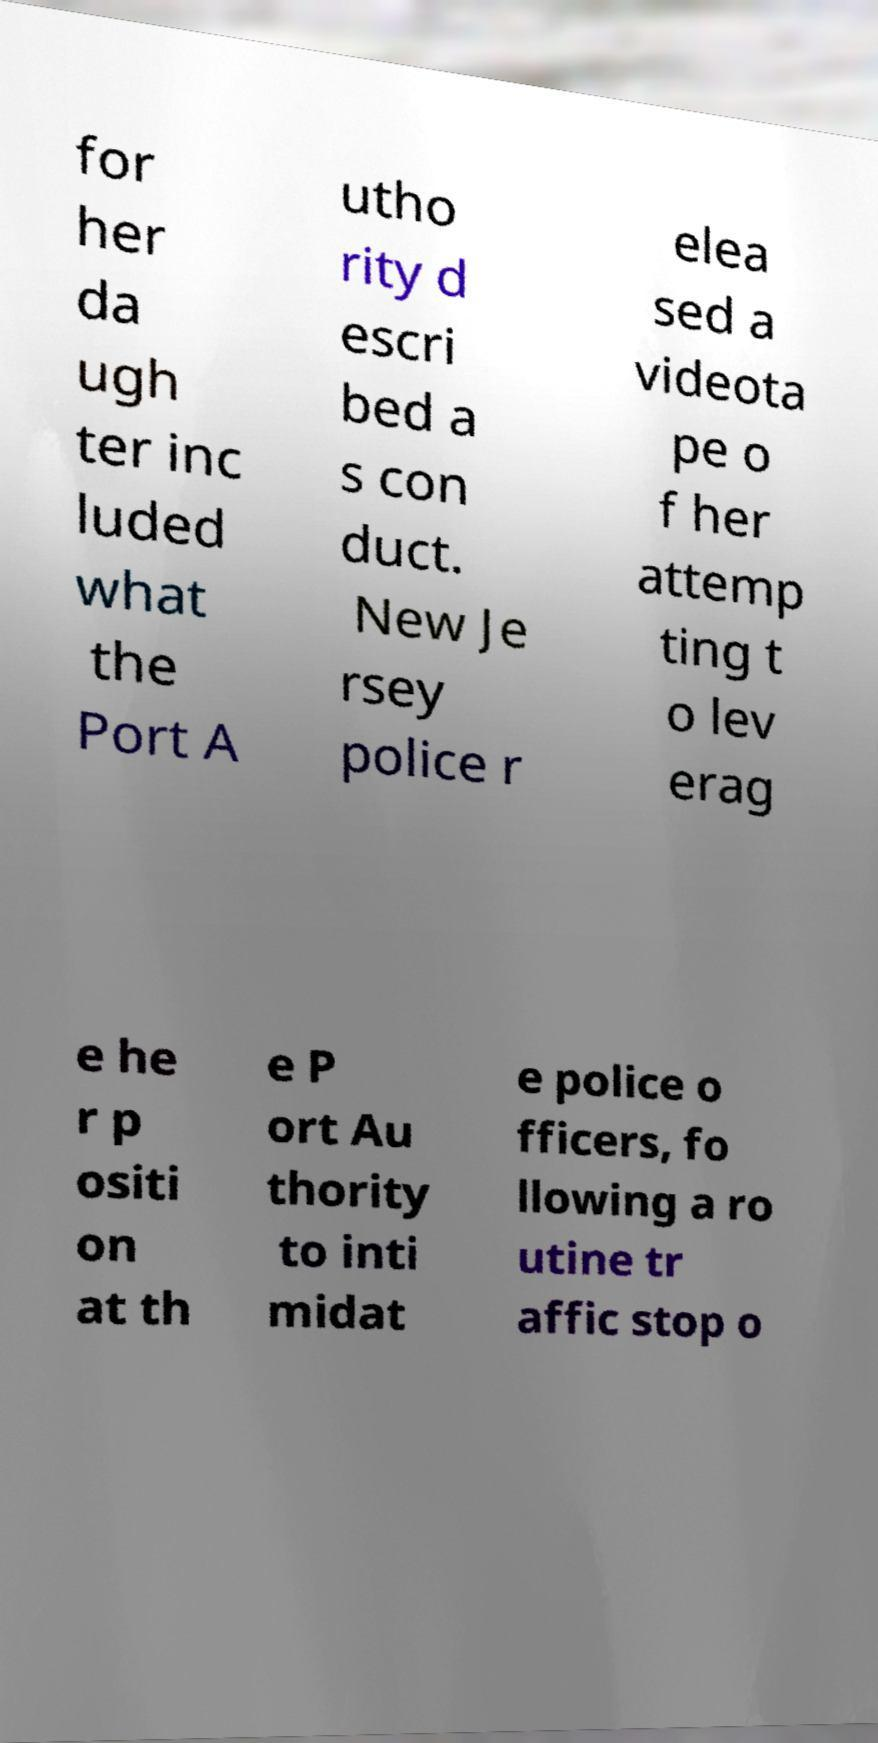I need the written content from this picture converted into text. Can you do that? for her da ugh ter inc luded what the Port A utho rity d escri bed a s con duct. New Je rsey police r elea sed a videota pe o f her attemp ting t o lev erag e he r p ositi on at th e P ort Au thority to inti midat e police o fficers, fo llowing a ro utine tr affic stop o 